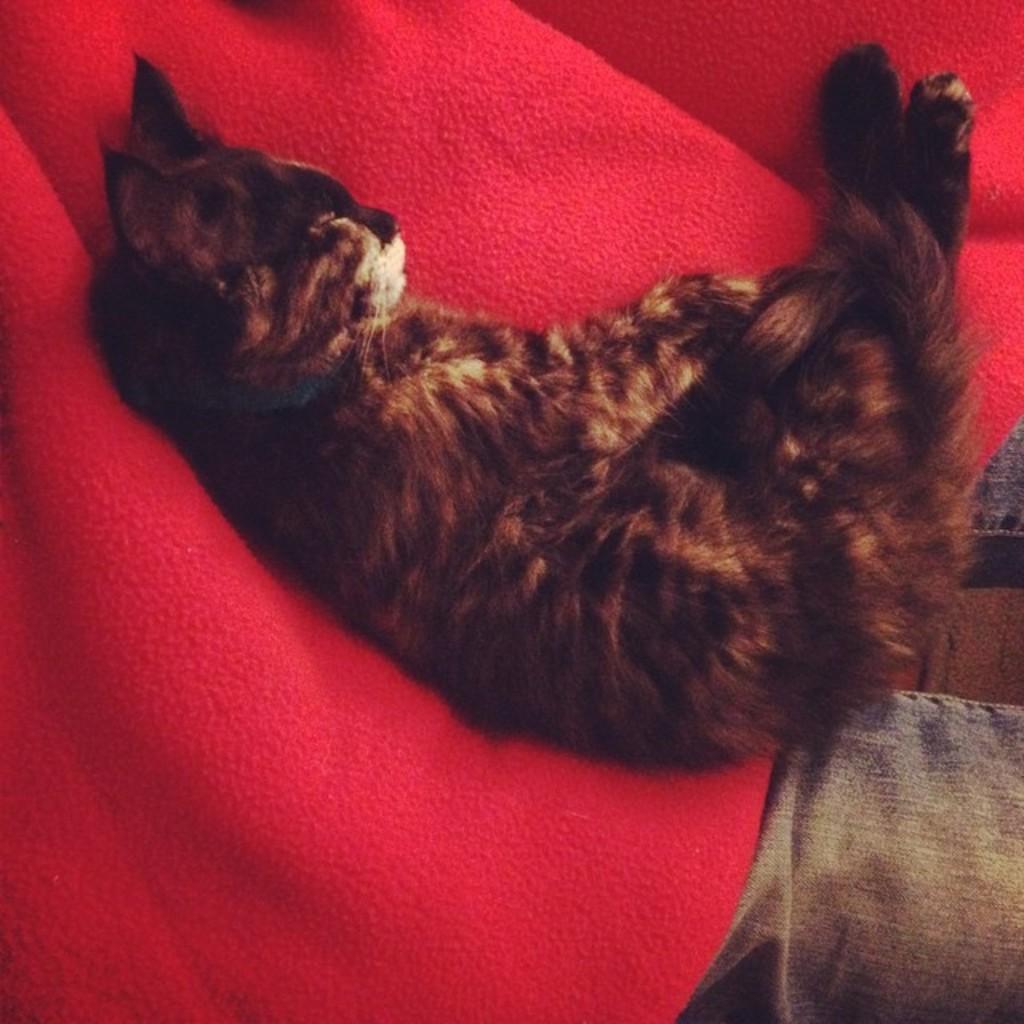Please provide a concise description of this image. In the middle of the image a cat is sleeping on the person's shirt. In the background there is a person with a red color shirt. 